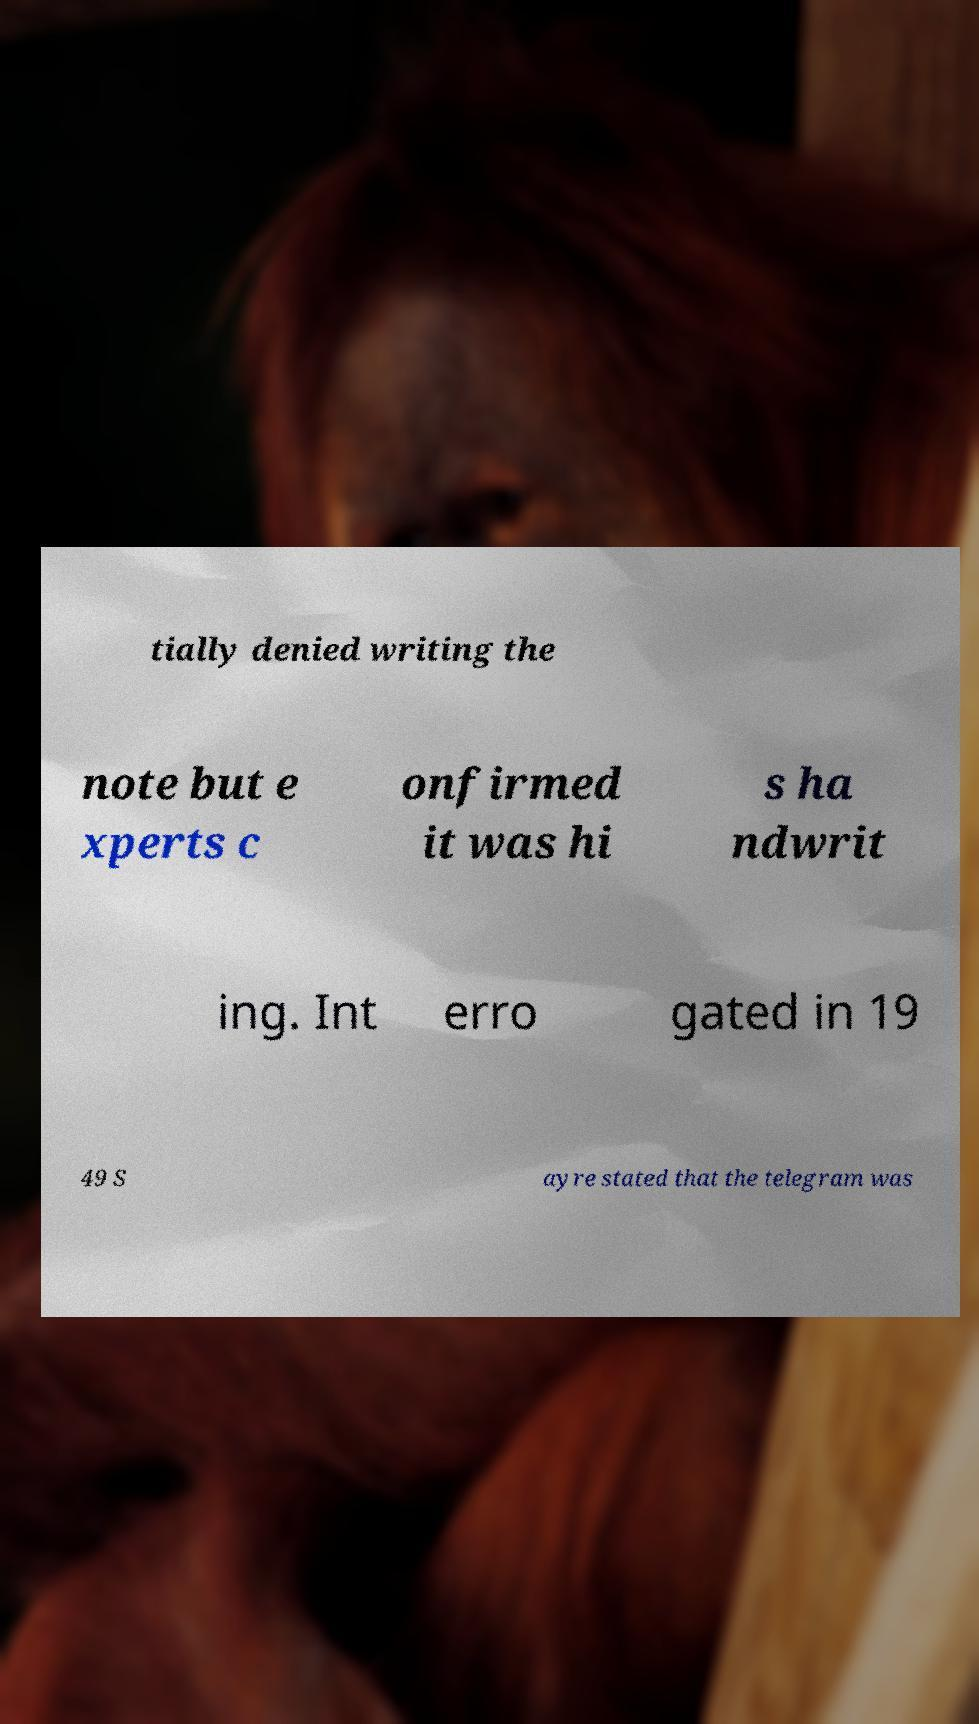What messages or text are displayed in this image? I need them in a readable, typed format. tially denied writing the note but e xperts c onfirmed it was hi s ha ndwrit ing. Int erro gated in 19 49 S ayre stated that the telegram was 